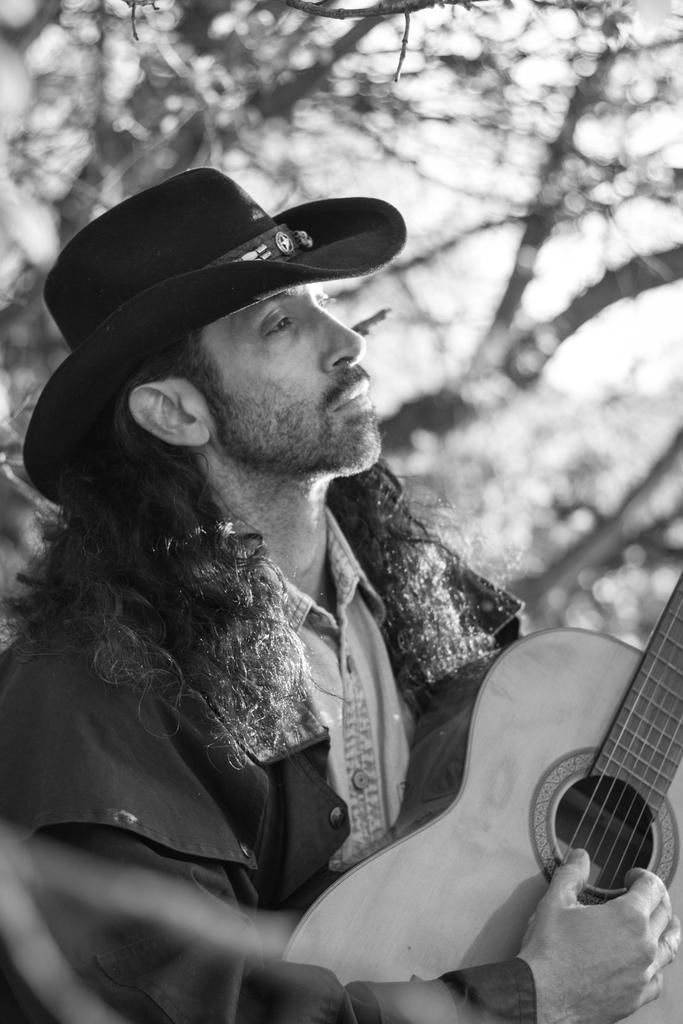How would you summarize this image in a sentence or two? This picture shows a man standing and playing a guitar we see trees on his back 